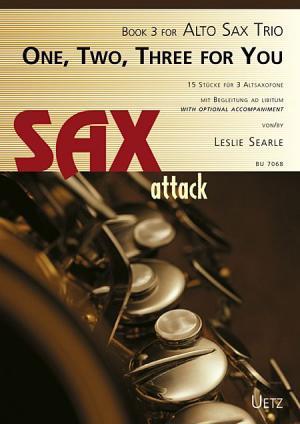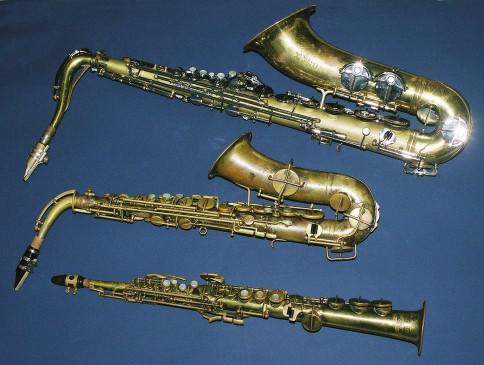The first image is the image on the left, the second image is the image on the right. Evaluate the accuracy of this statement regarding the images: "The only instruments shown are woodwinds.". Is it true? Answer yes or no. Yes. The first image is the image on the left, the second image is the image on the right. Given the left and right images, does the statement "At least one image includes a keyboard in a scene with a saxophone." hold true? Answer yes or no. No. 